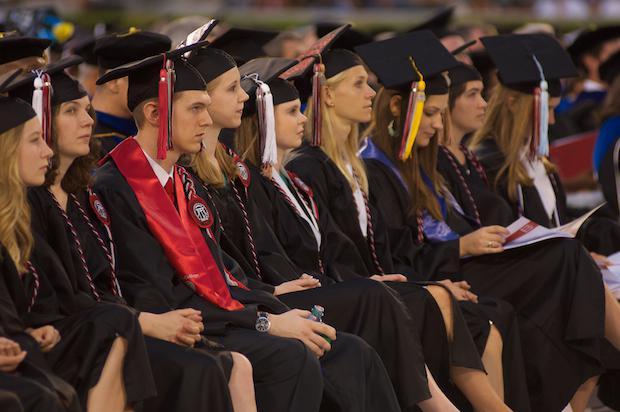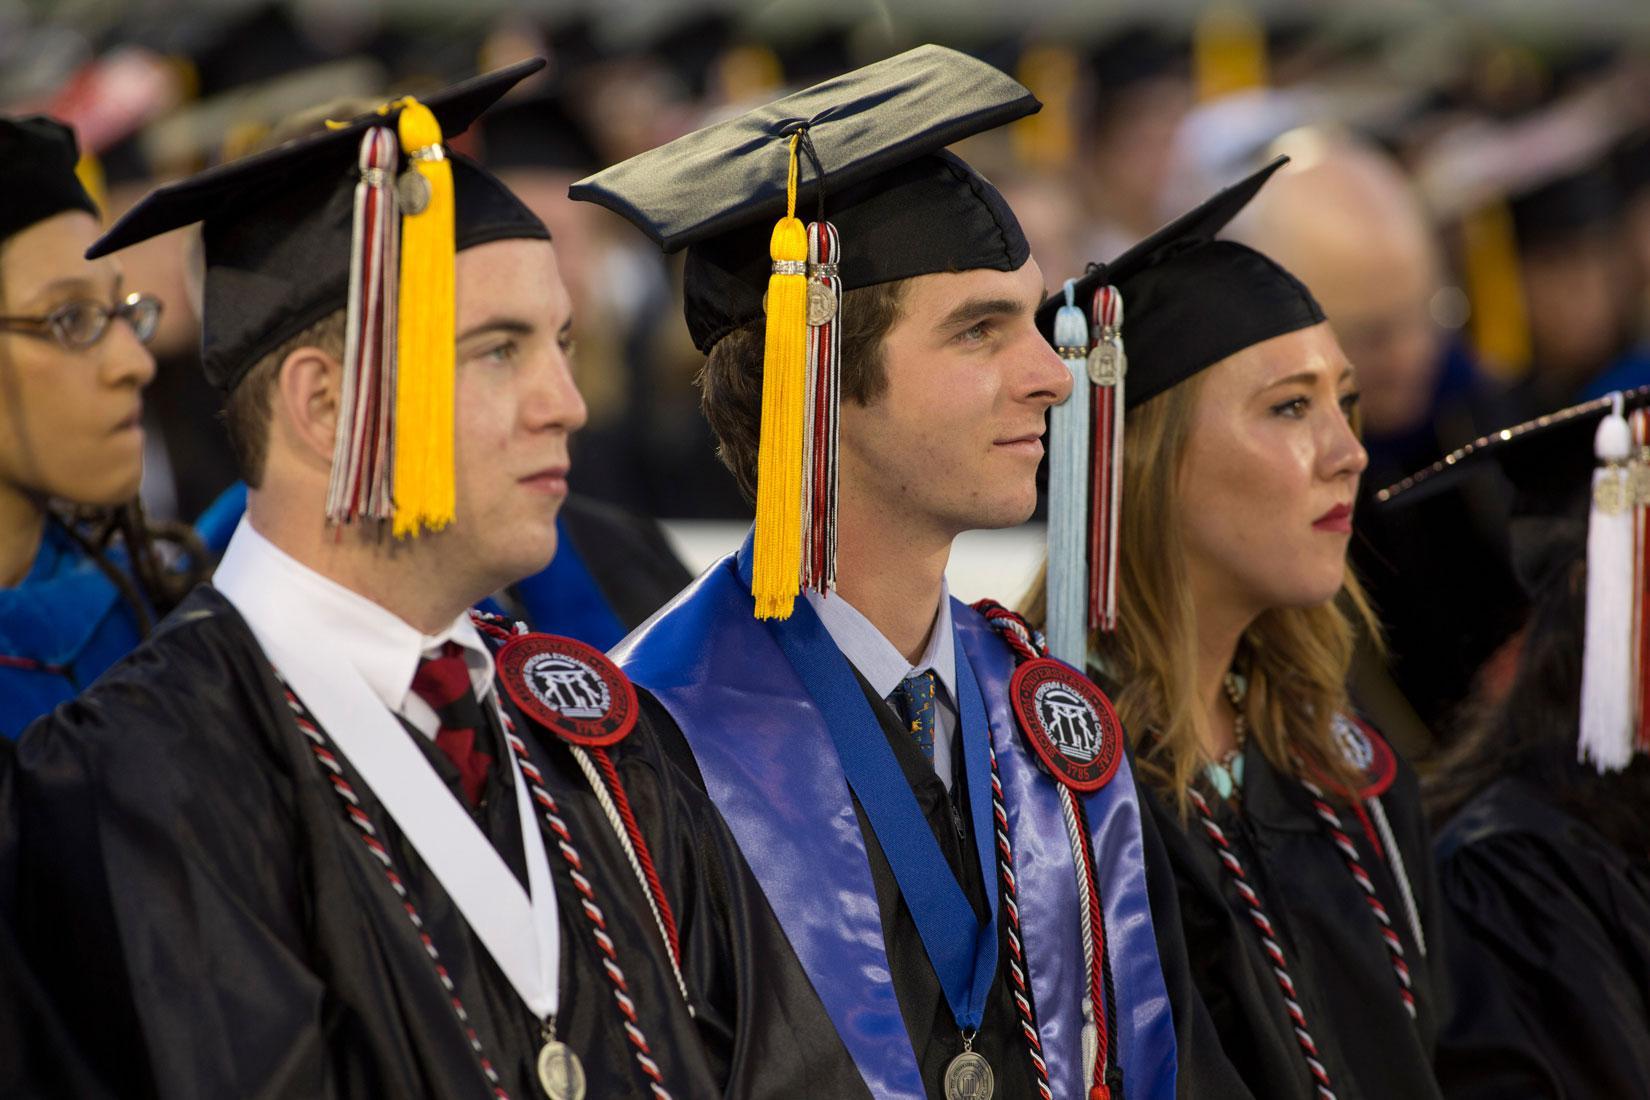The first image is the image on the left, the second image is the image on the right. For the images shown, is this caption "There are at most two graduates in the left image." true? Answer yes or no. No. The first image is the image on the left, the second image is the image on the right. Examine the images to the left and right. Is the description "Some of the people's tassels on their hats are yellow." accurate? Answer yes or no. Yes. 